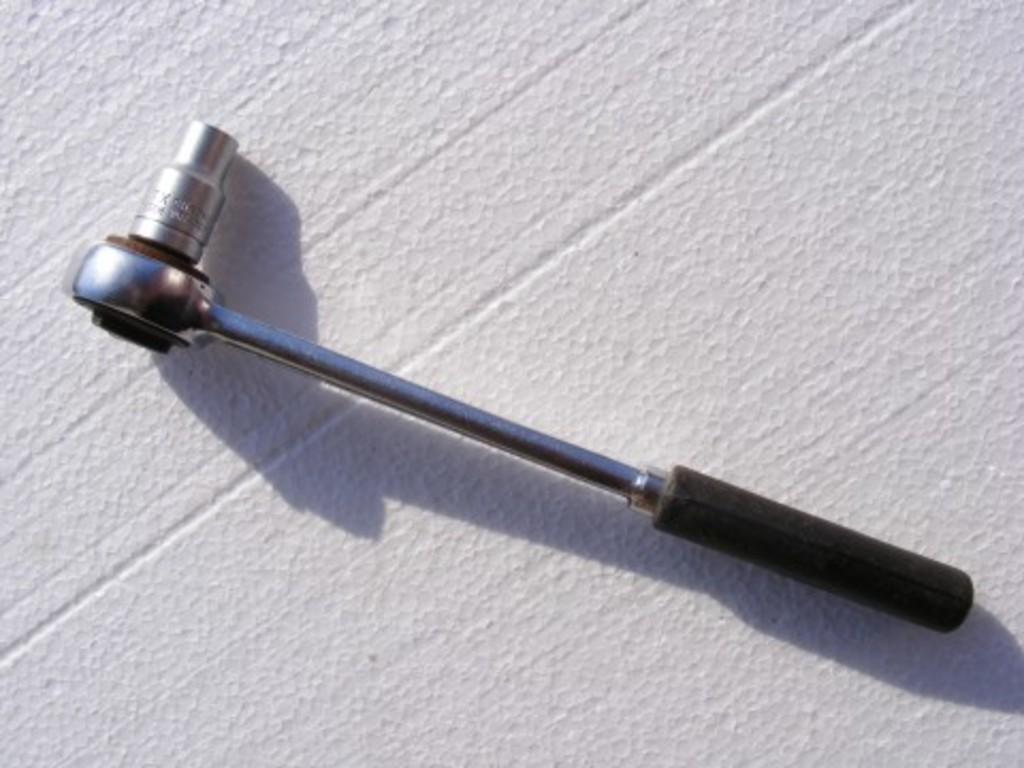What is the color of the surface in the image? The surface in the image is white. What can be seen on the white surface? There are tools with black handles on the surface. Is there a jail visible in the image? No, there is no jail present in the image. What part of the tools can be seen in the image? The handles of the tools are visible in the image, and they are black. 